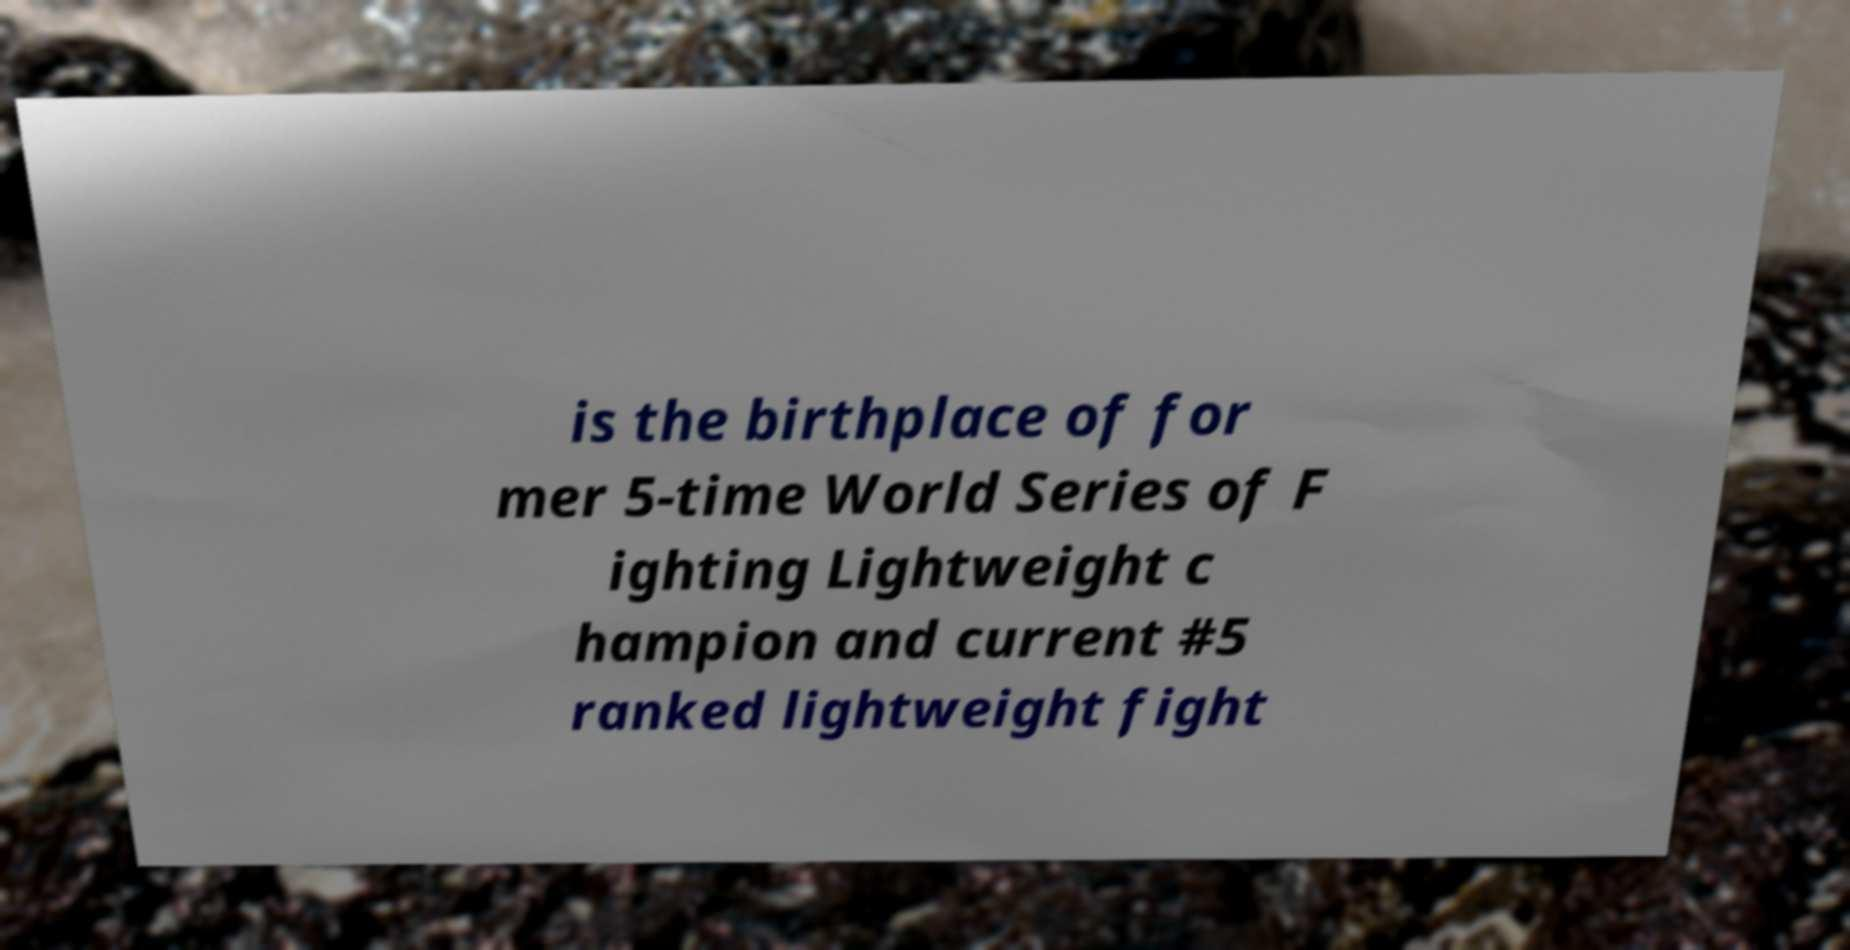For documentation purposes, I need the text within this image transcribed. Could you provide that? is the birthplace of for mer 5-time World Series of F ighting Lightweight c hampion and current #5 ranked lightweight fight 